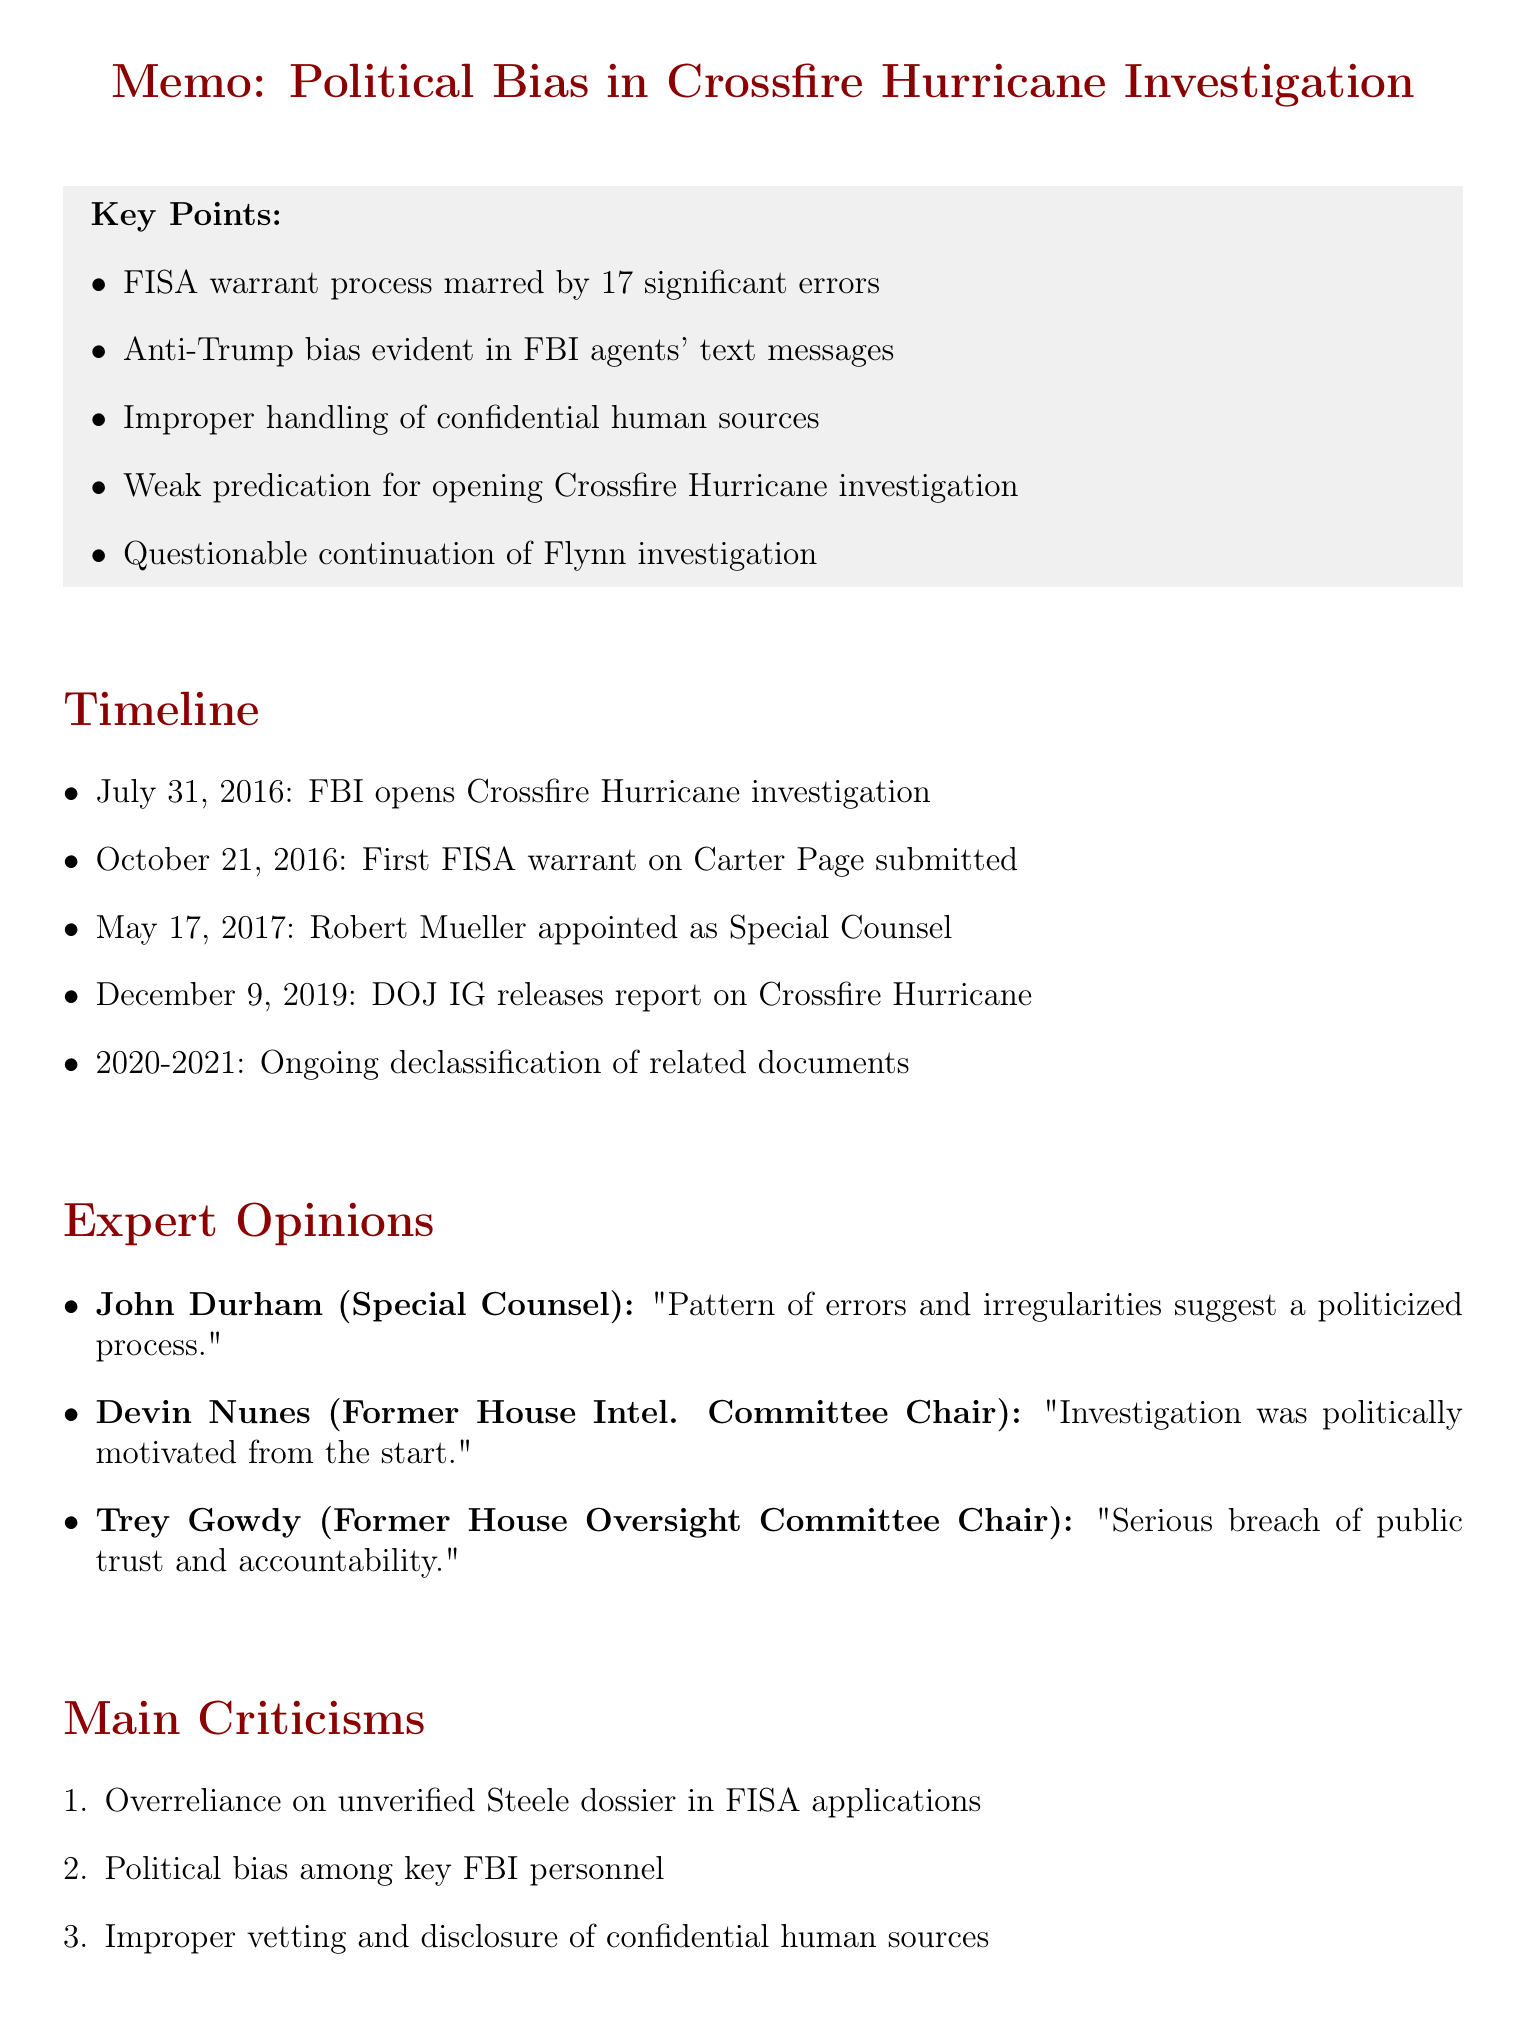What was the date the Crossfire Hurricane investigation was opened? The date the investigation was opened is explicitly stated in the timeline section of the document.
Answer: July 31, 2016 How many significant errors were found in the FISA warrant process? The number of significant errors is mentioned in the key points regarding the FISA warrant issues.
Answer: 17 Who was removed from the Mueller investigation? The individual who was removed is identified in the section discussing Strzok and Page text messages.
Answer: Peter Strzok What did John Durham describe the investigation as being marred by? The description given by John Durham summarizes the problems with the investigation highlighted in the expert opinions section.
Answer: Errors and irregularities What was the intelligence that triggered the opening of the Crossfire Hurricane investigation? This information is specified in the key points regarding the initiation of the investigation.
Answer: Vague information from Alexander Downer What does the document suggest about the FBI's handling of the Steele dossier? The criticism section highlights specific concerns regarding the FBI's use of the Steele dossier in their applications.
Answer: Overreliance on unverified dossier Which FBI agent's text messages indicated political bias? The names of the agents involved are mentioned in the key points regarding text messages.
Answer: Peter Strzok and Lisa Page What year did the DOJ Inspector General release the report on Crossfire Hurricane? This date is listed in the timeline portion of the document.
Answer: December 9, 2019 What specific topic is addressed in the "Flynn Investigation Closure Memo"? The topic is indicated within the key points related to the Flynn investigation.
Answer: Continuing the investigation without clear justification 